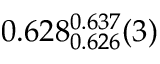Convert formula to latex. <formula><loc_0><loc_0><loc_500><loc_500>0 . 6 2 8 _ { 0 . 6 2 6 } ^ { 0 . 6 3 7 } ( 3 )</formula> 